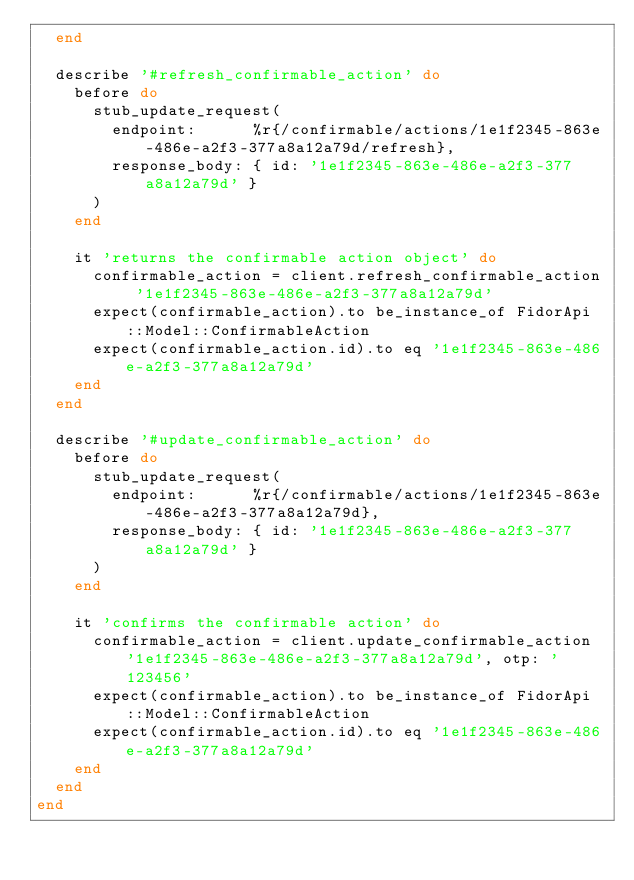Convert code to text. <code><loc_0><loc_0><loc_500><loc_500><_Ruby_>  end

  describe '#refresh_confirmable_action' do
    before do
      stub_update_request(
        endpoint:      %r{/confirmable/actions/1e1f2345-863e-486e-a2f3-377a8a12a79d/refresh},
        response_body: { id: '1e1f2345-863e-486e-a2f3-377a8a12a79d' }
      )
    end

    it 'returns the confirmable action object' do
      confirmable_action = client.refresh_confirmable_action '1e1f2345-863e-486e-a2f3-377a8a12a79d'
      expect(confirmable_action).to be_instance_of FidorApi::Model::ConfirmableAction
      expect(confirmable_action.id).to eq '1e1f2345-863e-486e-a2f3-377a8a12a79d'
    end
  end

  describe '#update_confirmable_action' do
    before do
      stub_update_request(
        endpoint:      %r{/confirmable/actions/1e1f2345-863e-486e-a2f3-377a8a12a79d},
        response_body: { id: '1e1f2345-863e-486e-a2f3-377a8a12a79d' }
      )
    end

    it 'confirms the confirmable action' do
      confirmable_action = client.update_confirmable_action '1e1f2345-863e-486e-a2f3-377a8a12a79d', otp: '123456'
      expect(confirmable_action).to be_instance_of FidorApi::Model::ConfirmableAction
      expect(confirmable_action.id).to eq '1e1f2345-863e-486e-a2f3-377a8a12a79d'
    end
  end
end
</code> 